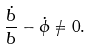<formula> <loc_0><loc_0><loc_500><loc_500>\frac { \dot { b } } { b } - \dot { \phi } \neq 0 .</formula> 